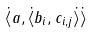Convert formula to latex. <formula><loc_0><loc_0><loc_500><loc_500>\dot { \langle } a , \dot { \langle } b _ { i } , c _ { i , j } \dot { \rangle } \dot { \rangle }</formula> 